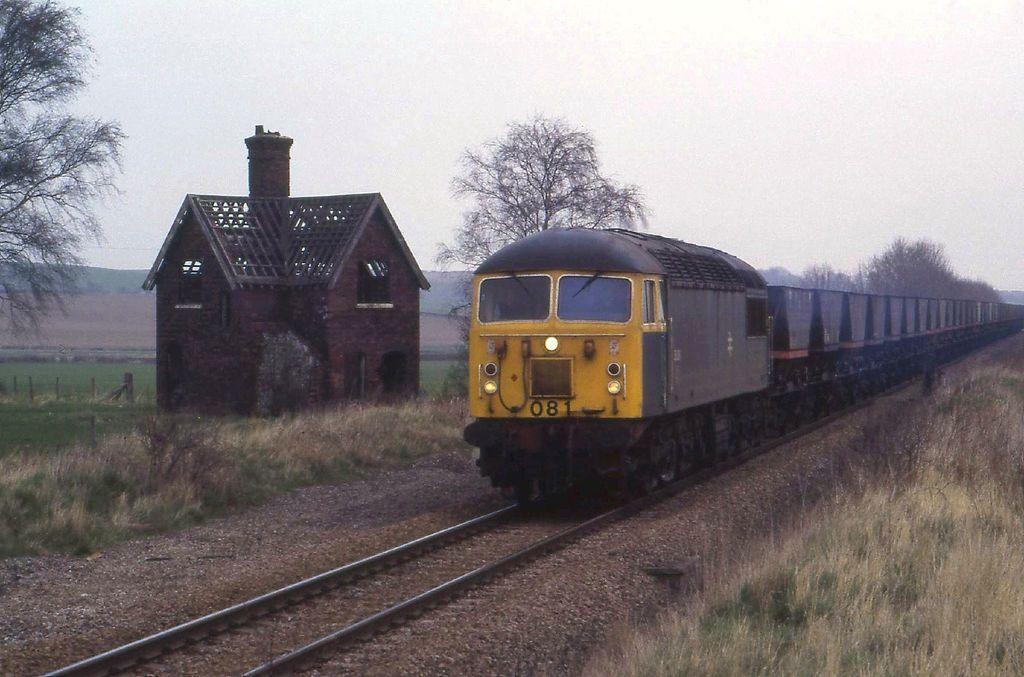Please provide a concise description of this image. In this picture we can see a train on a railway track, shed, trees, grass, fence and in the background we can see the sky. 